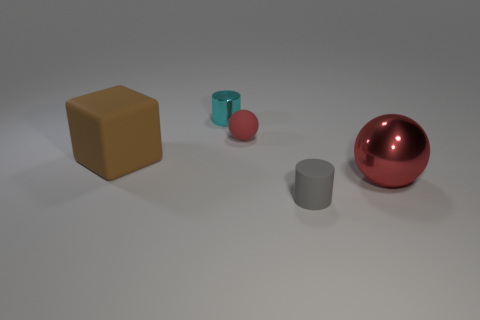There is a big thing that is the same shape as the tiny red rubber thing; what material is it?
Your response must be concise. Metal. The tiny matte object that is in front of the matte thing that is on the left side of the red thing on the left side of the red shiny object is what color?
Ensure brevity in your answer.  Gray. How many objects are either small gray things or tiny metallic spheres?
Your response must be concise. 1. What number of cyan metallic things are the same shape as the small gray rubber object?
Ensure brevity in your answer.  1. Does the large sphere have the same material as the red sphere that is behind the big matte cube?
Your answer should be compact. No. The red sphere that is made of the same material as the small gray cylinder is what size?
Your response must be concise. Small. What is the size of the cylinder behind the small gray cylinder?
Give a very brief answer. Small. How many red matte cubes have the same size as the gray cylinder?
Ensure brevity in your answer.  0. What size is the other shiny ball that is the same color as the small sphere?
Keep it short and to the point. Large. Is there a shiny sphere that has the same color as the tiny matte cylinder?
Make the answer very short. No. 